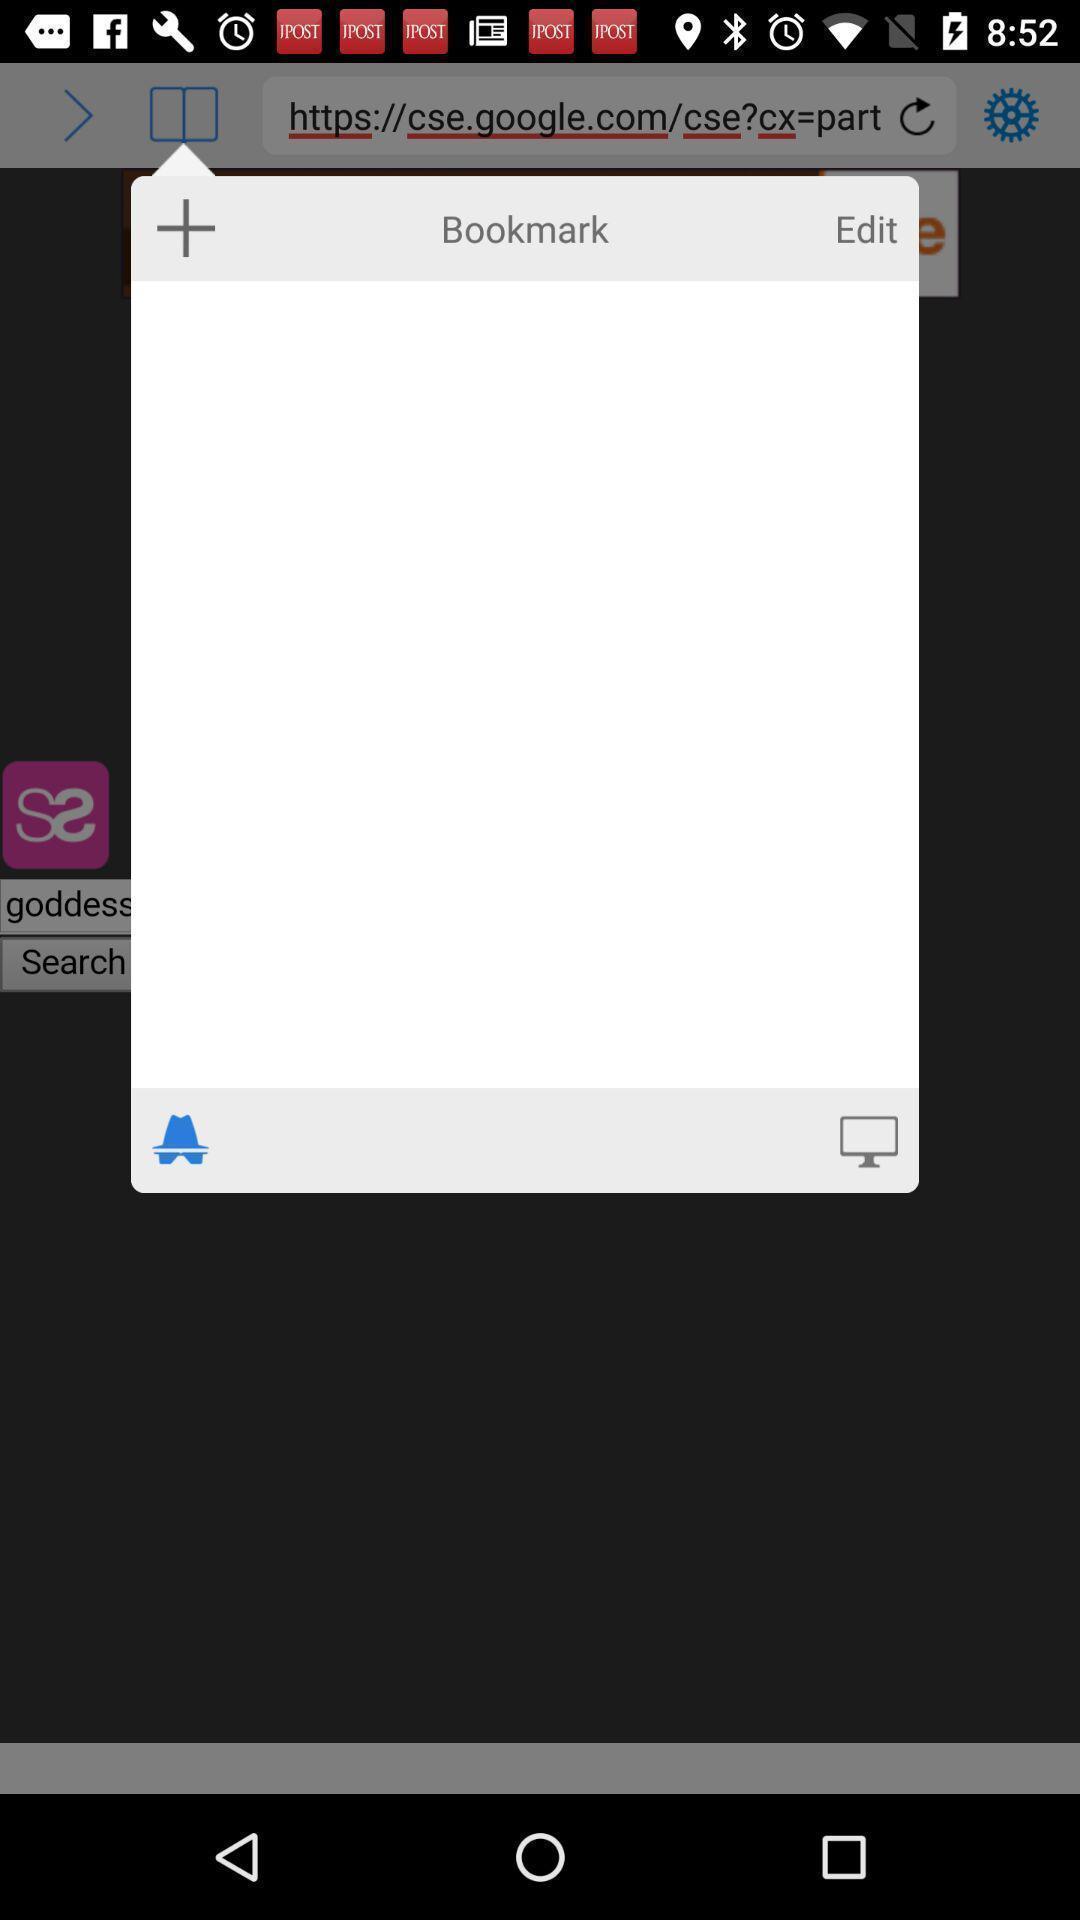Explain the elements present in this screenshot. Pop-up showing an option to edit a bookmark. 